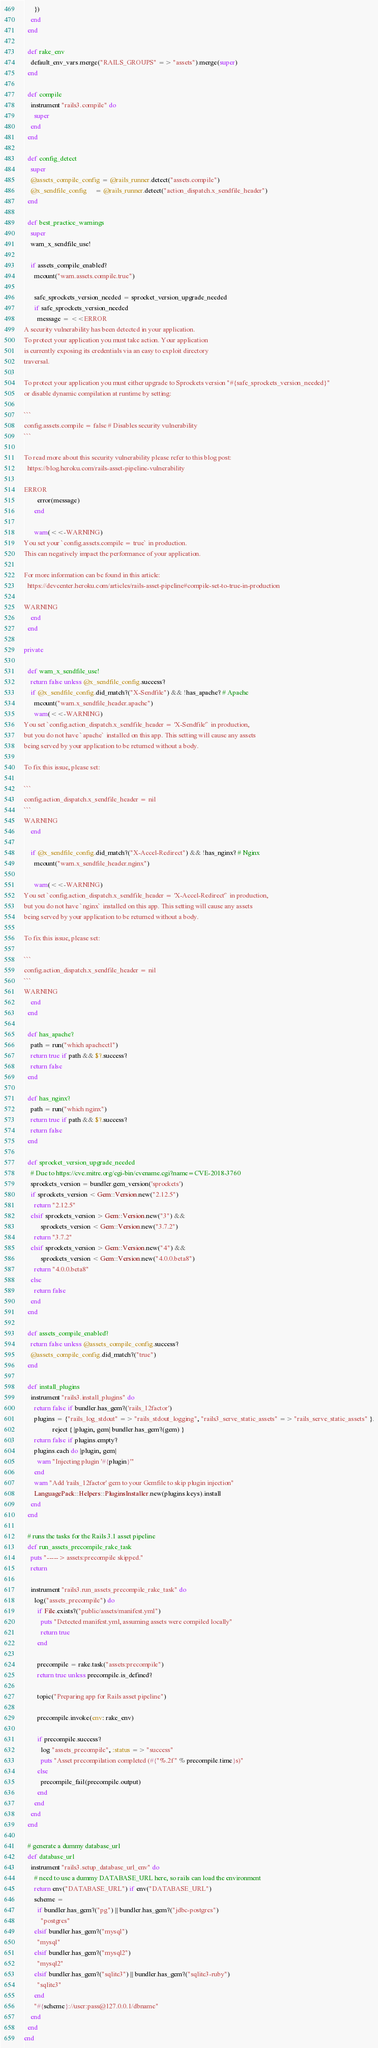<code> <loc_0><loc_0><loc_500><loc_500><_Ruby_>      })
    end
  end

  def rake_env
    default_env_vars.merge("RAILS_GROUPS" => "assets").merge(super)
  end

  def compile
    instrument "rails3.compile" do
      super
    end
  end

  def config_detect
    super
    @assets_compile_config = @rails_runner.detect("assets.compile")
    @x_sendfile_config     = @rails_runner.detect("action_dispatch.x_sendfile_header")
  end

  def best_practice_warnings
    super
    warn_x_sendfile_use!

    if assets_compile_enabled?
      mcount("warn.assets.compile.true")

      safe_sprockets_version_needed = sprocket_version_upgrade_needed
      if safe_sprockets_version_needed
        message = <<ERROR
A security vulnerability has been detected in your application.
To protect your application you must take action. Your application
is currently exposing its credentials via an easy to exploit directory
traversal.

To protect your application you must either upgrade to Sprockets version "#{safe_sprockets_version_needed}"
or disable dynamic compilation at runtime by setting:

```
config.assets.compile = false # Disables security vulnerability
```

To read more about this security vulnerability please refer to this blog post:
  https://blog.heroku.com/rails-asset-pipeline-vulnerability

ERROR
        error(message)
      end

      warn(<<-WARNING)
You set your `config.assets.compile = true` in production.
This can negatively impact the performance of your application.

For more information can be found in this article:
  https://devcenter.heroku.com/articles/rails-asset-pipeline#compile-set-to-true-in-production

WARNING
    end
  end

private

  def warn_x_sendfile_use!
    return false unless @x_sendfile_config.success?
    if @x_sendfile_config.did_match?("X-Sendfile") && !has_apache? # Apache
      mcount("warn.x_sendfile_header.apache")
      warn(<<-WARNING)
You set `config.action_dispatch.x_sendfile_header = 'X-Sendfile'` in production,
but you do not have `apache` installed on this app. This setting will cause any assets
being served by your application to be returned without a body.

To fix this issue, please set:

```
config.action_dispatch.x_sendfile_header = nil
```
WARNING
    end

    if @x_sendfile_config.did_match?("X-Accel-Redirect") && !has_nginx? # Nginx
      mcount("warn.x_sendfile_header.nginx")

      warn(<<-WARNING)
You set `config.action_dispatch.x_sendfile_header = 'X-Accel-Redirect'` in production,
but you do not have `nginx` installed on this app. This setting will cause any assets
being served by your application to be returned without a body.

To fix this issue, please set:

```
config.action_dispatch.x_sendfile_header = nil
```
WARNING
    end
  end

  def has_apache?
    path = run("which apachectl")
    return true if path && $?.success?
    return false
  end

  def has_nginx?
    path = run("which nginx")
    return true if path && $?.success?
    return false
  end

  def sprocket_version_upgrade_needed
    # Due to https://cve.mitre.org/cgi-bin/cvename.cgi?name=CVE-2018-3760
    sprockets_version = bundler.gem_version('sprockets')
    if sprockets_version < Gem::Version.new("2.12.5")
      return "2.12.5"
    elsif sprockets_version > Gem::Version.new("3") &&
          sprockets_version < Gem::Version.new("3.7.2")
      return "3.7.2"
    elsif sprockets_version > Gem::Version.new("4") &&
          sprockets_version < Gem::Version.new("4.0.0.beta8")
      return "4.0.0.beta8"
    else
      return false
    end
  end

  def assets_compile_enabled?
    return false unless @assets_compile_config.success?
    @assets_compile_config.did_match?("true")
  end

  def install_plugins
    instrument "rails3.install_plugins" do
      return false if bundler.has_gem?('rails_12factor')
      plugins = {"rails_log_stdout" => "rails_stdout_logging", "rails3_serve_static_assets" => "rails_serve_static_assets" }.
                 reject { |plugin, gem| bundler.has_gem?(gem) }
      return false if plugins.empty?
      plugins.each do |plugin, gem|
        warn "Injecting plugin '#{plugin}'"
      end
      warn "Add 'rails_12factor' gem to your Gemfile to skip plugin injection"
      LanguagePack::Helpers::PluginsInstaller.new(plugins.keys).install
    end
  end

  # runs the tasks for the Rails 3.1 asset pipeline
  def run_assets_precompile_rake_task
    puts "-----> assets:precompile skipped."
    return

    instrument "rails3.run_assets_precompile_rake_task" do
      log("assets_precompile") do
        if File.exists?("public/assets/manifest.yml")
          puts "Detected manifest.yml, assuming assets were compiled locally"
          return true
        end

        precompile = rake.task("assets:precompile")
        return true unless precompile.is_defined?

        topic("Preparing app for Rails asset pipeline")

        precompile.invoke(env: rake_env)

        if precompile.success?
          log "assets_precompile", :status => "success"
          puts "Asset precompilation completed (#{"%.2f" % precompile.time}s)"
        else
          precompile_fail(precompile.output)
        end
      end
    end
  end

  # generate a dummy database_url
  def database_url
    instrument "rails3.setup_database_url_env" do
      # need to use a dummy DATABASE_URL here, so rails can load the environment
      return env("DATABASE_URL") if env("DATABASE_URL")
      scheme =
        if bundler.has_gem?("pg") || bundler.has_gem?("jdbc-postgres")
          "postgres"
      elsif bundler.has_gem?("mysql")
        "mysql"
      elsif bundler.has_gem?("mysql2")
        "mysql2"
      elsif bundler.has_gem?("sqlite3") || bundler.has_gem?("sqlite3-ruby")
        "sqlite3"
      end
      "#{scheme}://user:pass@127.0.0.1/dbname"
    end
  end
end
</code> 